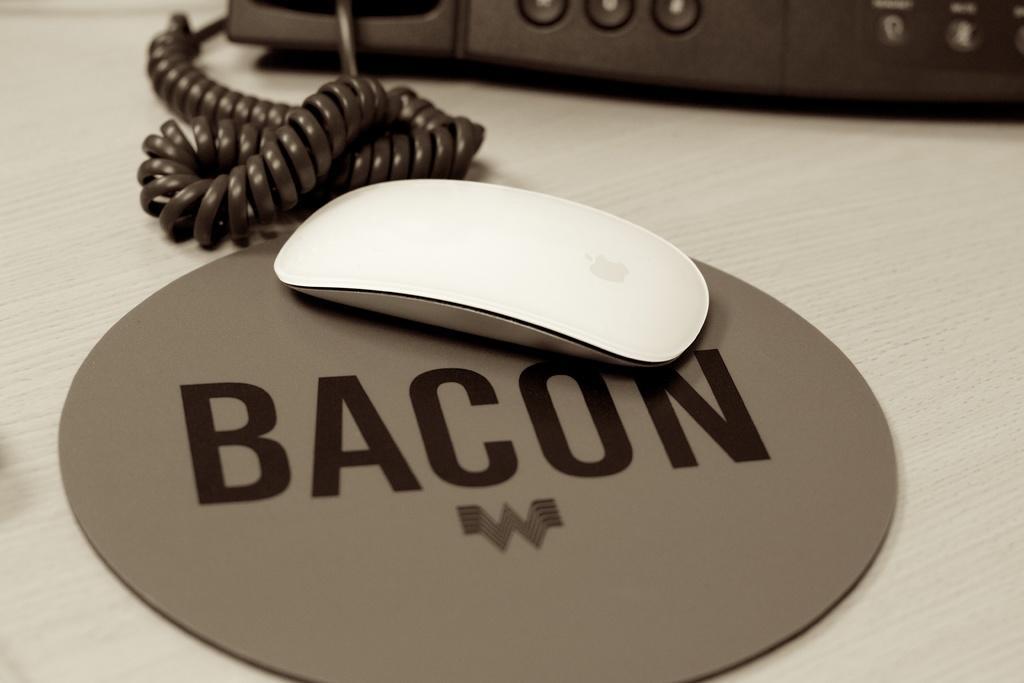How would you summarize this image in a sentence or two? This is the picture of a place where we have a mouse which is in white color and behind there is a telephone. 